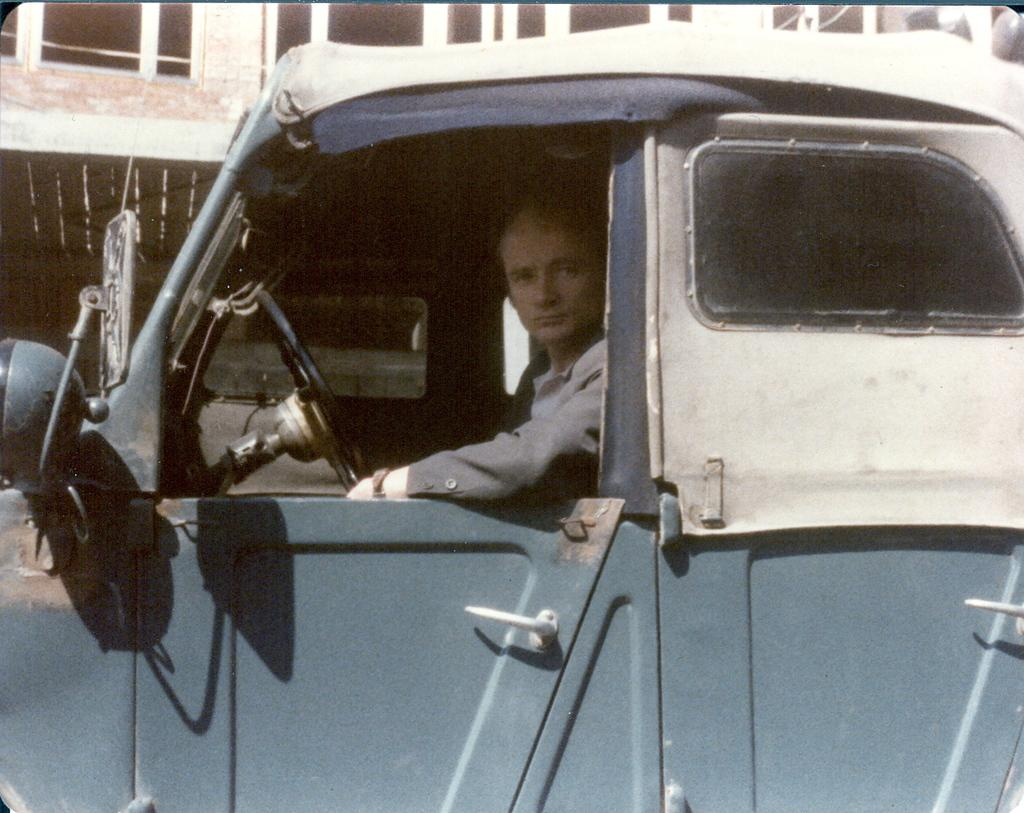Who is inside the car in the image? There is a man in the car. What color is the car? The car is blue in color. Are there any other colors visible on the car? Yes, the back side of the car is white. What can be seen in the background of the image? There is a building in the background of the image. What type of game is the man playing in the car? There is no indication in the image that the man is playing a game, so it cannot be determined from the picture. 